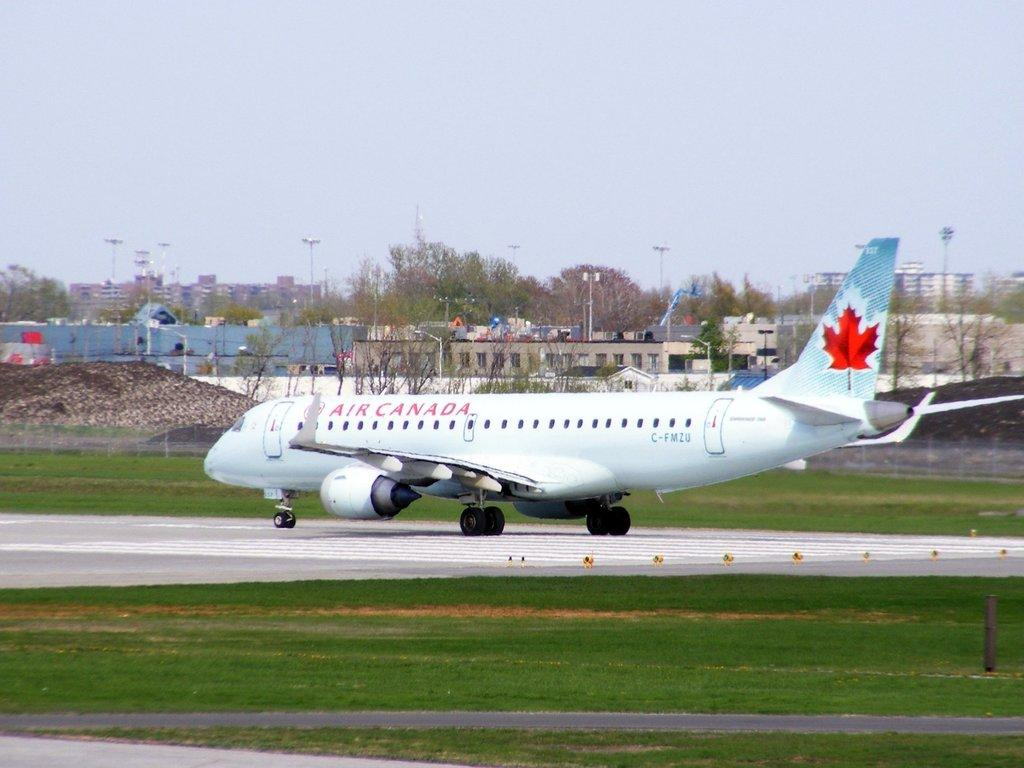What is the main subject of the image? The main subject of the image is a flight. What can be seen on the runway in the image? There are small yellow objects on the runway in the image. What type of barrier is present in the image? There is a fence in the image. What type of vegetation is visible in the image? Grass and trees are visible in the image. What type of structures are present in the image? Buildings and towers are present in the image. What is illuminating the area in the image? Lights are present on poles in the image. What part of the natural environment is visible in the image? The sky is visible in the image. What type of drink is being served to the passengers on the flight in the image? The image does not show any drinks being served to passengers, so it cannot be determined from the image. 